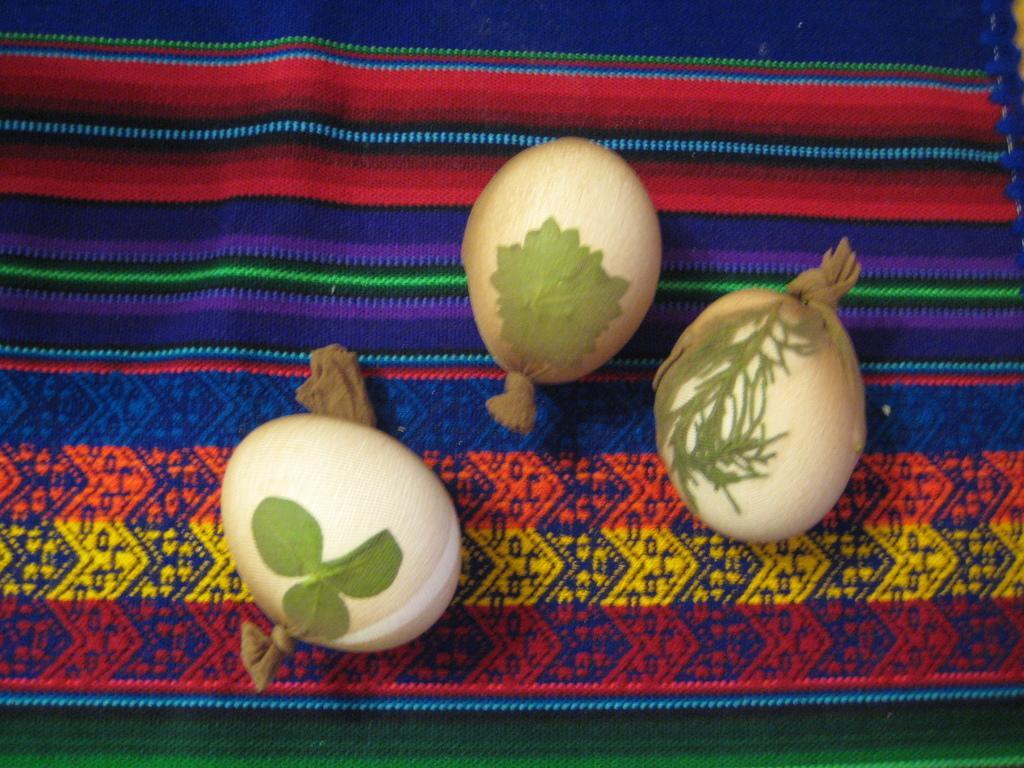Can you describe this image briefly? In this image, we can see some objects on the mat. 